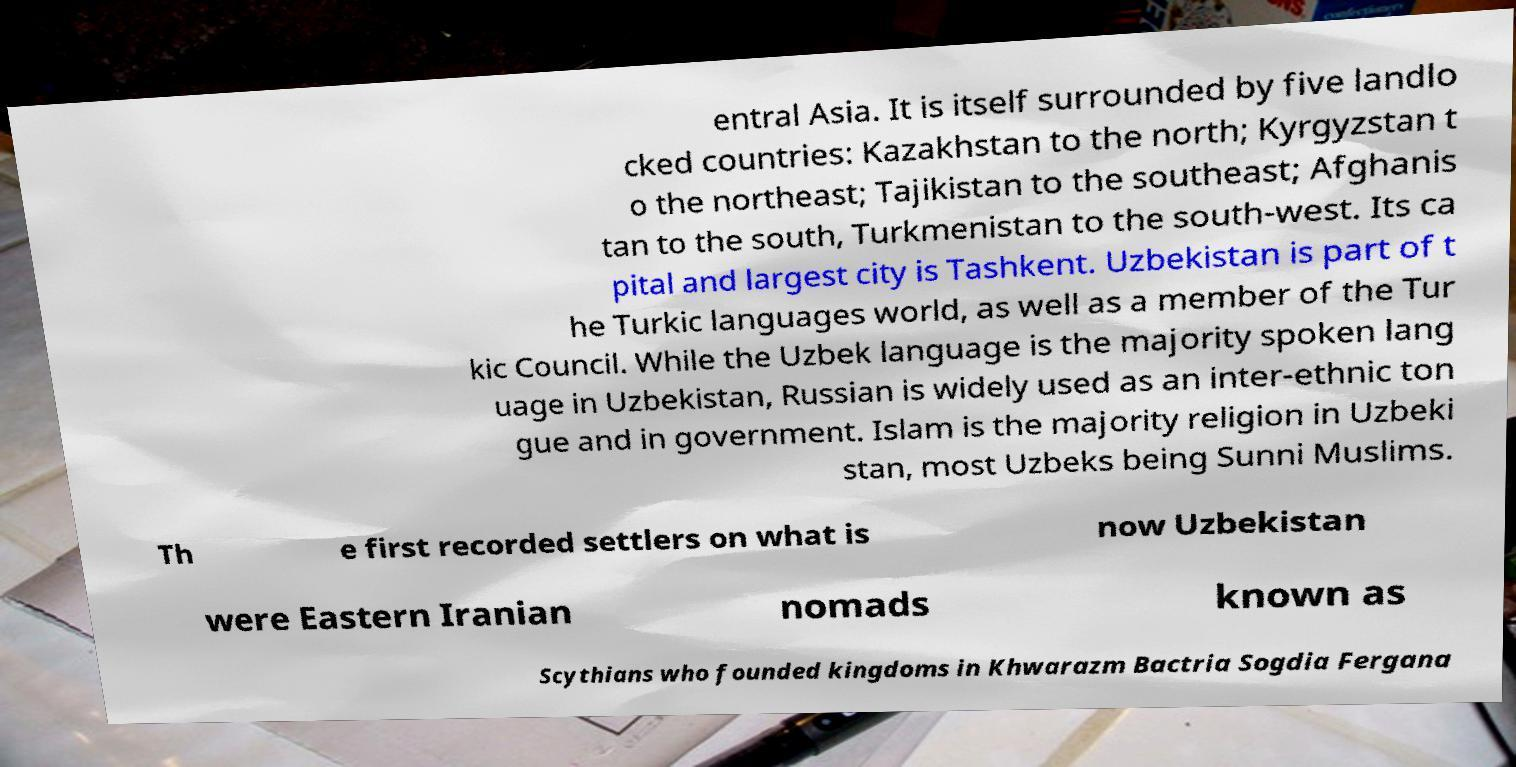Can you read and provide the text displayed in the image?This photo seems to have some interesting text. Can you extract and type it out for me? entral Asia. It is itself surrounded by five landlo cked countries: Kazakhstan to the north; Kyrgyzstan t o the northeast; Tajikistan to the southeast; Afghanis tan to the south, Turkmenistan to the south-west. Its ca pital and largest city is Tashkent. Uzbekistan is part of t he Turkic languages world, as well as a member of the Tur kic Council. While the Uzbek language is the majority spoken lang uage in Uzbekistan, Russian is widely used as an inter-ethnic ton gue and in government. Islam is the majority religion in Uzbeki stan, most Uzbeks being Sunni Muslims. Th e first recorded settlers on what is now Uzbekistan were Eastern Iranian nomads known as Scythians who founded kingdoms in Khwarazm Bactria Sogdia Fergana 